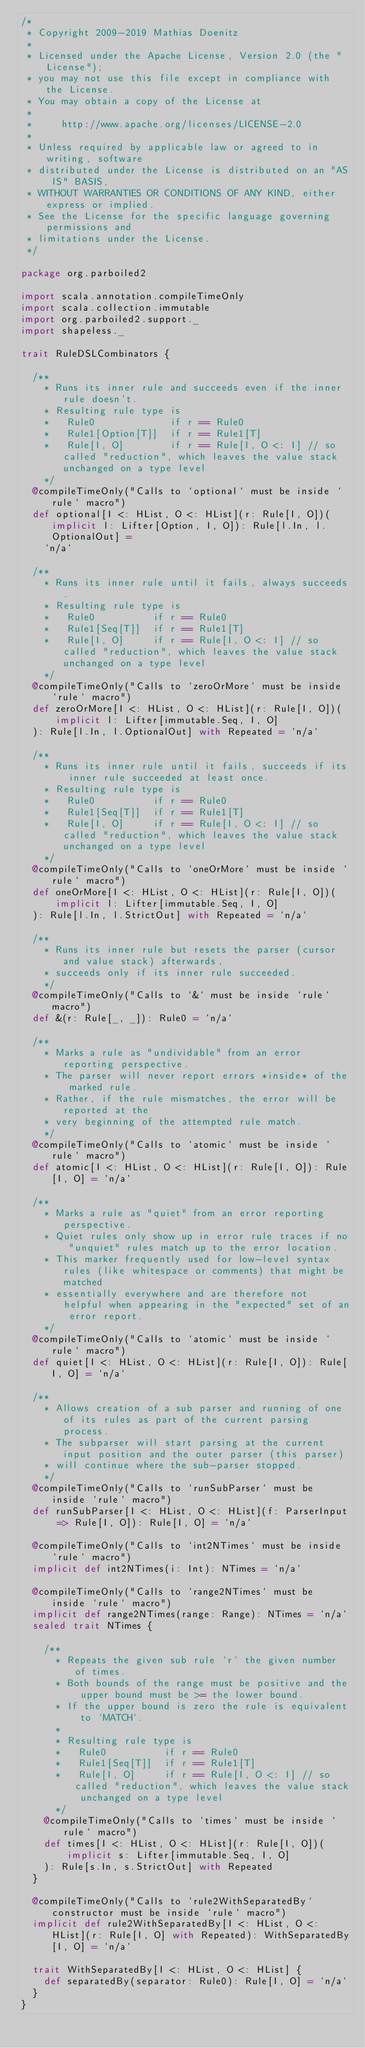Convert code to text. <code><loc_0><loc_0><loc_500><loc_500><_Scala_>/*
 * Copyright 2009-2019 Mathias Doenitz
 *
 * Licensed under the Apache License, Version 2.0 (the "License");
 * you may not use this file except in compliance with the License.
 * You may obtain a copy of the License at
 *
 *     http://www.apache.org/licenses/LICENSE-2.0
 *
 * Unless required by applicable law or agreed to in writing, software
 * distributed under the License is distributed on an "AS IS" BASIS,
 * WITHOUT WARRANTIES OR CONDITIONS OF ANY KIND, either express or implied.
 * See the License for the specific language governing permissions and
 * limitations under the License.
 */

package org.parboiled2

import scala.annotation.compileTimeOnly
import scala.collection.immutable
import org.parboiled2.support._
import shapeless._

trait RuleDSLCombinators {

  /**
    * Runs its inner rule and succeeds even if the inner rule doesn't.
    * Resulting rule type is
    *   Rule0             if r == Rule0
    *   Rule1[Option[T]]  if r == Rule1[T]
    *   Rule[I, O]        if r == Rule[I, O <: I] // so called "reduction", which leaves the value stack unchanged on a type level
    */
  @compileTimeOnly("Calls to `optional` must be inside `rule` macro")
  def optional[I <: HList, O <: HList](r: Rule[I, O])(implicit l: Lifter[Option, I, O]): Rule[l.In, l.OptionalOut] =
    `n/a`

  /**
    * Runs its inner rule until it fails, always succeeds.
    * Resulting rule type is
    *   Rule0          if r == Rule0
    *   Rule1[Seq[T]]  if r == Rule1[T]
    *   Rule[I, O]     if r == Rule[I, O <: I] // so called "reduction", which leaves the value stack unchanged on a type level
    */
  @compileTimeOnly("Calls to `zeroOrMore` must be inside `rule` macro")
  def zeroOrMore[I <: HList, O <: HList](r: Rule[I, O])(
      implicit l: Lifter[immutable.Seq, I, O]
  ): Rule[l.In, l.OptionalOut] with Repeated = `n/a`

  /**
    * Runs its inner rule until it fails, succeeds if its inner rule succeeded at least once.
    * Resulting rule type is
    *   Rule0          if r == Rule0
    *   Rule1[Seq[T]]  if r == Rule1[T]
    *   Rule[I, O]     if r == Rule[I, O <: I] // so called "reduction", which leaves the value stack unchanged on a type level
    */
  @compileTimeOnly("Calls to `oneOrMore` must be inside `rule` macro")
  def oneOrMore[I <: HList, O <: HList](r: Rule[I, O])(
      implicit l: Lifter[immutable.Seq, I, O]
  ): Rule[l.In, l.StrictOut] with Repeated = `n/a`

  /**
    * Runs its inner rule but resets the parser (cursor and value stack) afterwards,
    * succeeds only if its inner rule succeeded.
    */
  @compileTimeOnly("Calls to `&` must be inside `rule` macro")
  def &(r: Rule[_, _]): Rule0 = `n/a`

  /**
    * Marks a rule as "undividable" from an error reporting perspective.
    * The parser will never report errors *inside* of the marked rule.
    * Rather, if the rule mismatches, the error will be reported at the
    * very beginning of the attempted rule match.
    */
  @compileTimeOnly("Calls to `atomic` must be inside `rule` macro")
  def atomic[I <: HList, O <: HList](r: Rule[I, O]): Rule[I, O] = `n/a`

  /**
    * Marks a rule as "quiet" from an error reporting perspective.
    * Quiet rules only show up in error rule traces if no "unquiet" rules match up to the error location.
    * This marker frequently used for low-level syntax rules (like whitespace or comments) that might be matched
    * essentially everywhere and are therefore not helpful when appearing in the "expected" set of an error report.
    */
  @compileTimeOnly("Calls to `atomic` must be inside `rule` macro")
  def quiet[I <: HList, O <: HList](r: Rule[I, O]): Rule[I, O] = `n/a`

  /**
    * Allows creation of a sub parser and running of one of its rules as part of the current parsing process.
    * The subparser will start parsing at the current input position and the outer parser (this parser)
    * will continue where the sub-parser stopped.
    */
  @compileTimeOnly("Calls to `runSubParser` must be inside `rule` macro")
  def runSubParser[I <: HList, O <: HList](f: ParserInput => Rule[I, O]): Rule[I, O] = `n/a`

  @compileTimeOnly("Calls to `int2NTimes` must be inside `rule` macro")
  implicit def int2NTimes(i: Int): NTimes = `n/a`

  @compileTimeOnly("Calls to `range2NTimes` must be inside `rule` macro")
  implicit def range2NTimes(range: Range): NTimes = `n/a`
  sealed trait NTimes {

    /**
      * Repeats the given sub rule `r` the given number of times.
      * Both bounds of the range must be positive and the upper bound must be >= the lower bound.
      * If the upper bound is zero the rule is equivalent to `MATCH`.
      *
      * Resulting rule type is
      *   Rule0          if r == Rule0
      *   Rule1[Seq[T]]  if r == Rule1[T]
      *   Rule[I, O]     if r == Rule[I, O <: I] // so called "reduction", which leaves the value stack unchanged on a type level
      */
    @compileTimeOnly("Calls to `times` must be inside `rule` macro")
    def times[I <: HList, O <: HList](r: Rule[I, O])(
        implicit s: Lifter[immutable.Seq, I, O]
    ): Rule[s.In, s.StrictOut] with Repeated
  }

  @compileTimeOnly("Calls to `rule2WithSeparatedBy` constructor must be inside `rule` macro")
  implicit def rule2WithSeparatedBy[I <: HList, O <: HList](r: Rule[I, O] with Repeated): WithSeparatedBy[I, O] = `n/a`

  trait WithSeparatedBy[I <: HList, O <: HList] {
    def separatedBy(separator: Rule0): Rule[I, O] = `n/a`
  }
}
</code> 